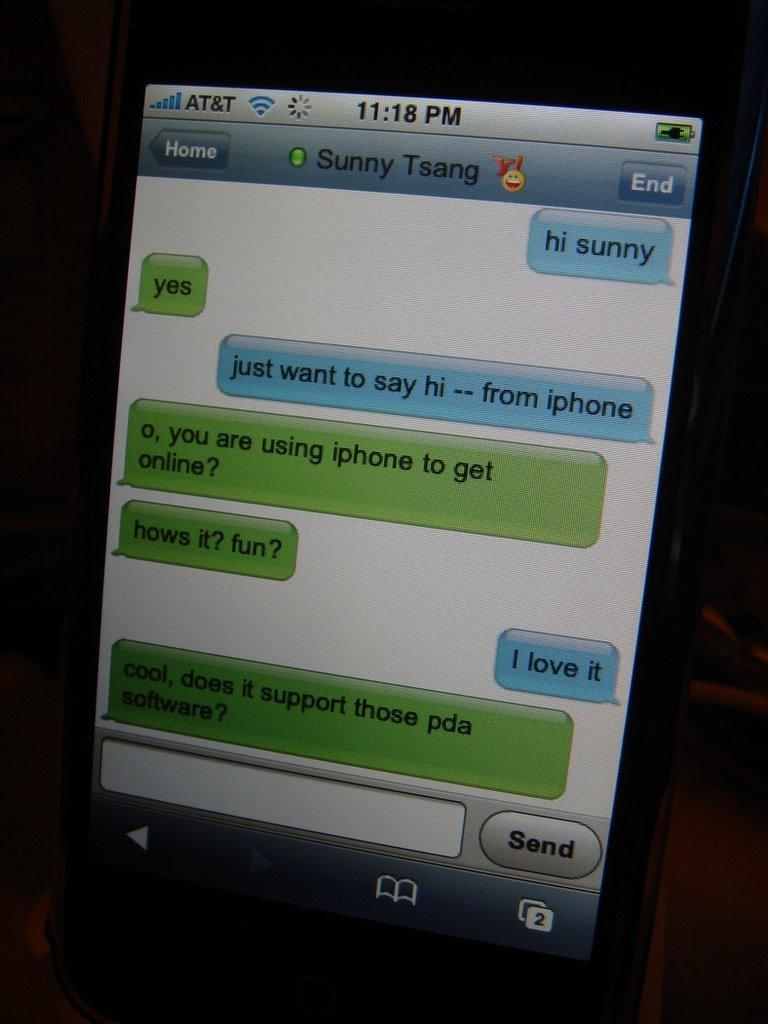<image>
Create a compact narrative representing the image presented. an iphone screen on to messages and the time reading 11:18 pm 